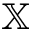Convert formula to latex. <formula><loc_0><loc_0><loc_500><loc_500>\mathbb { X }</formula> 